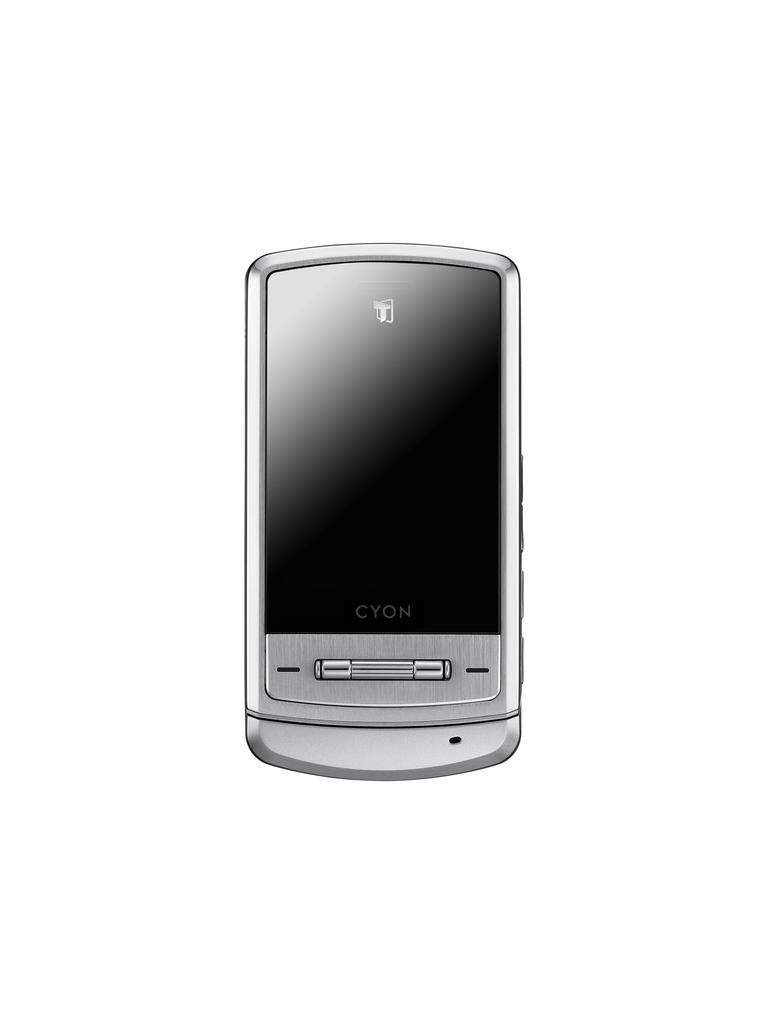<image>
Present a compact description of the photo's key features. a silver and black phone branded as 'cyon' 